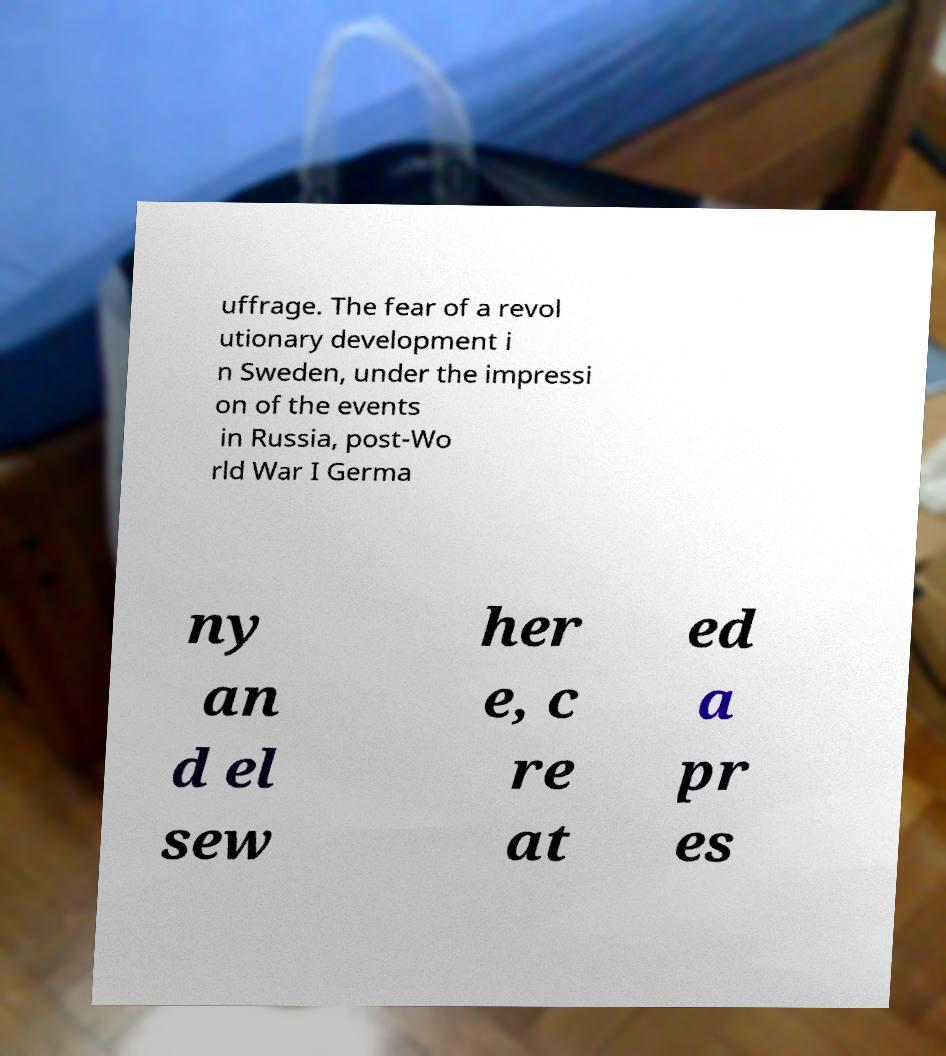There's text embedded in this image that I need extracted. Can you transcribe it verbatim? uffrage. The fear of a revol utionary development i n Sweden, under the impressi on of the events in Russia, post-Wo rld War I Germa ny an d el sew her e, c re at ed a pr es 